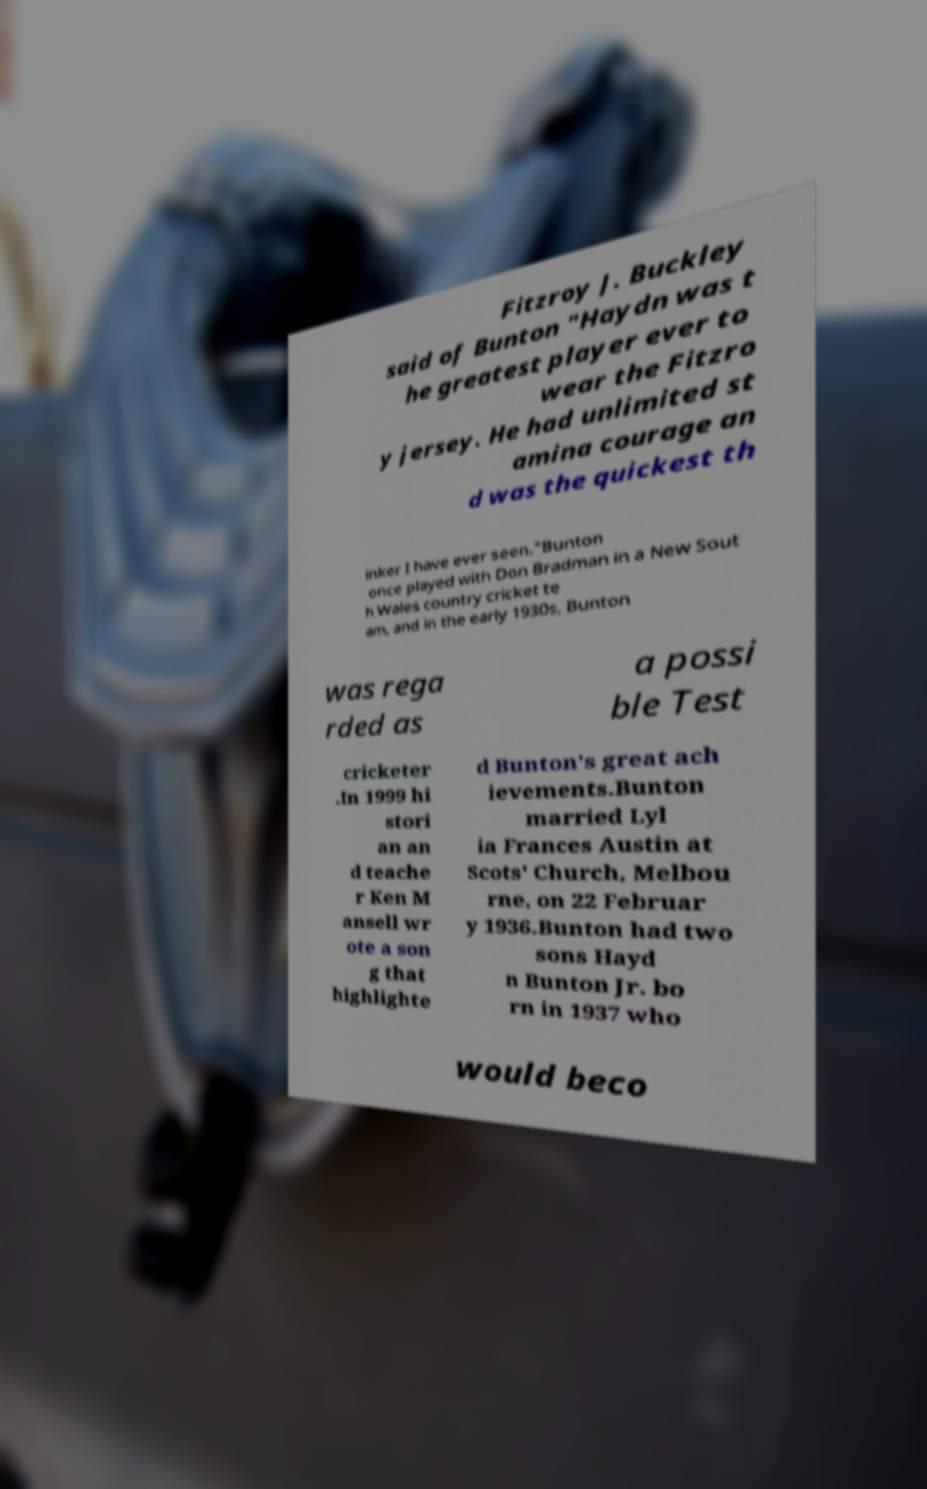There's text embedded in this image that I need extracted. Can you transcribe it verbatim? Fitzroy J. Buckley said of Bunton "Haydn was t he greatest player ever to wear the Fitzro y jersey. He had unlimited st amina courage an d was the quickest th inker I have ever seen."Bunton once played with Don Bradman in a New Sout h Wales country cricket te am, and in the early 1930s, Bunton was rega rded as a possi ble Test cricketer .In 1999 hi stori an an d teache r Ken M ansell wr ote a son g that highlighte d Bunton's great ach ievements.Bunton married Lyl ia Frances Austin at Scots' Church, Melbou rne, on 22 Februar y 1936.Bunton had two sons Hayd n Bunton Jr. bo rn in 1937 who would beco 